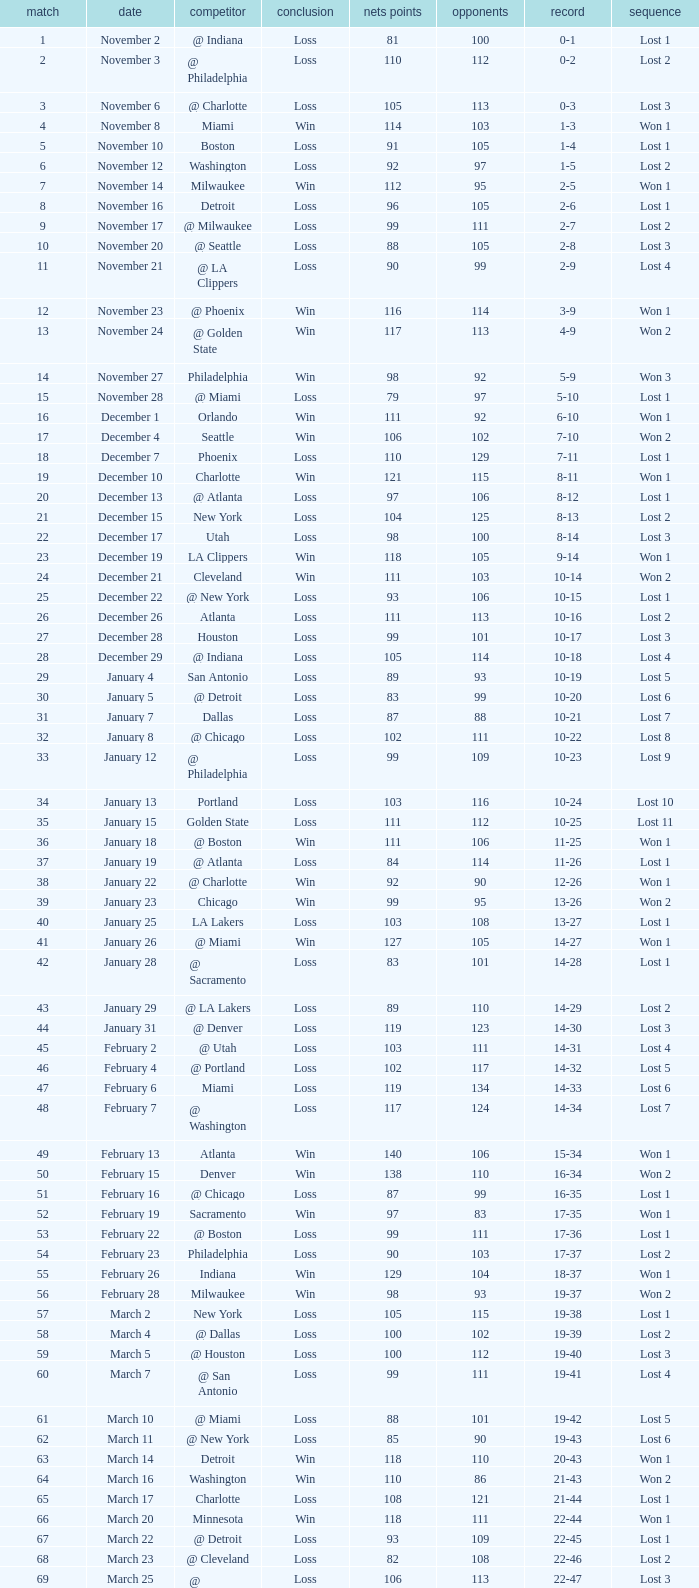In which game did the opponent score more than 103 and the record was 1-3? None. 